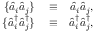<formula> <loc_0><loc_0><loc_500><loc_500>\begin{array} { r l r } { \{ \hat { a } _ { i } \hat { a } _ { j } \} } & \equiv } & { \hat { a } _ { i } \hat { a } _ { j } , } \\ { \{ \hat { a } _ { i } ^ { \dagger } \hat { a } _ { j } ^ { \dagger } \} } & \equiv } & { \hat { a } _ { i } ^ { \dagger } \hat { a } _ { j } ^ { \dagger } , } \end{array}</formula> 